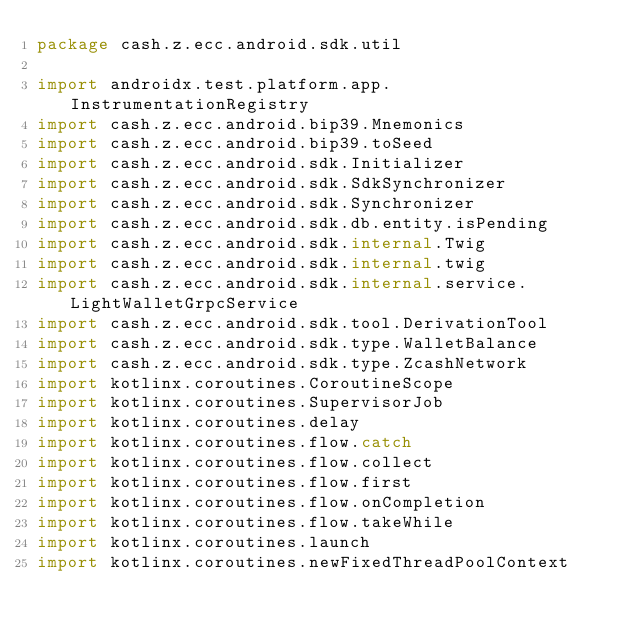<code> <loc_0><loc_0><loc_500><loc_500><_Kotlin_>package cash.z.ecc.android.sdk.util

import androidx.test.platform.app.InstrumentationRegistry
import cash.z.ecc.android.bip39.Mnemonics
import cash.z.ecc.android.bip39.toSeed
import cash.z.ecc.android.sdk.Initializer
import cash.z.ecc.android.sdk.SdkSynchronizer
import cash.z.ecc.android.sdk.Synchronizer
import cash.z.ecc.android.sdk.db.entity.isPending
import cash.z.ecc.android.sdk.internal.Twig
import cash.z.ecc.android.sdk.internal.twig
import cash.z.ecc.android.sdk.internal.service.LightWalletGrpcService
import cash.z.ecc.android.sdk.tool.DerivationTool
import cash.z.ecc.android.sdk.type.WalletBalance
import cash.z.ecc.android.sdk.type.ZcashNetwork
import kotlinx.coroutines.CoroutineScope
import kotlinx.coroutines.SupervisorJob
import kotlinx.coroutines.delay
import kotlinx.coroutines.flow.catch
import kotlinx.coroutines.flow.collect
import kotlinx.coroutines.flow.first
import kotlinx.coroutines.flow.onCompletion
import kotlinx.coroutines.flow.takeWhile
import kotlinx.coroutines.launch
import kotlinx.coroutines.newFixedThreadPoolContext</code> 